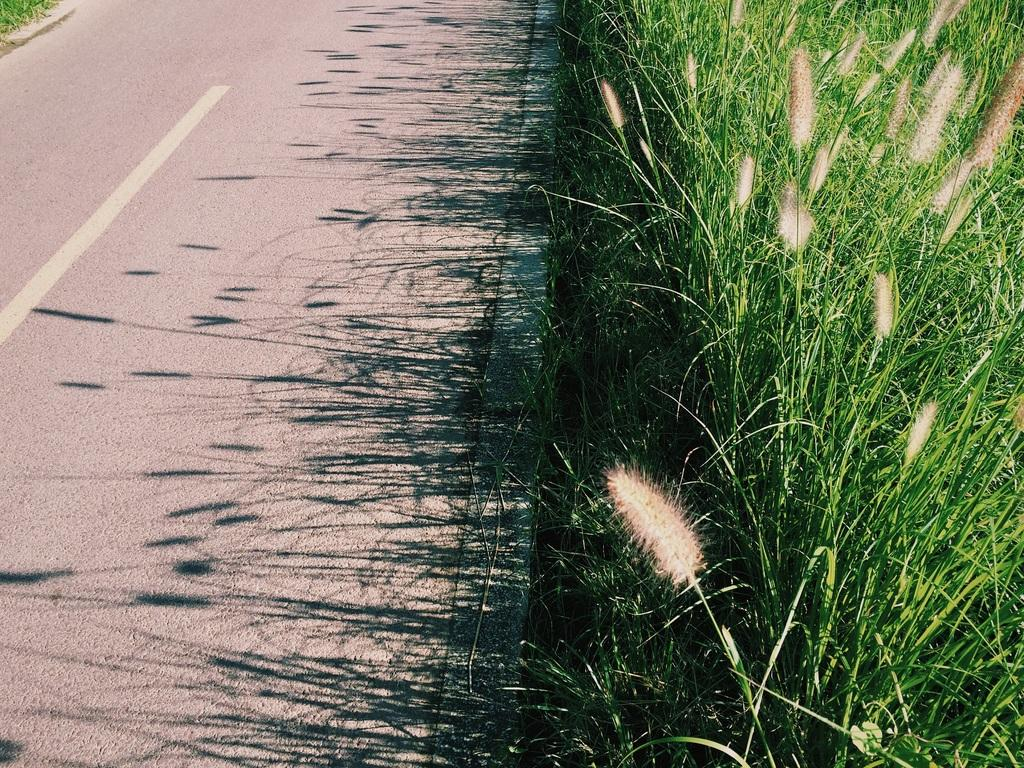What is the main feature of the image? There is a road in the image. What type of vegetation can be seen on the right side of the image? There is green color grass on the right side of the image. How does the person compare the sheet in the image? There is no person or sheet present in the image, so it is not possible to answer that question. 